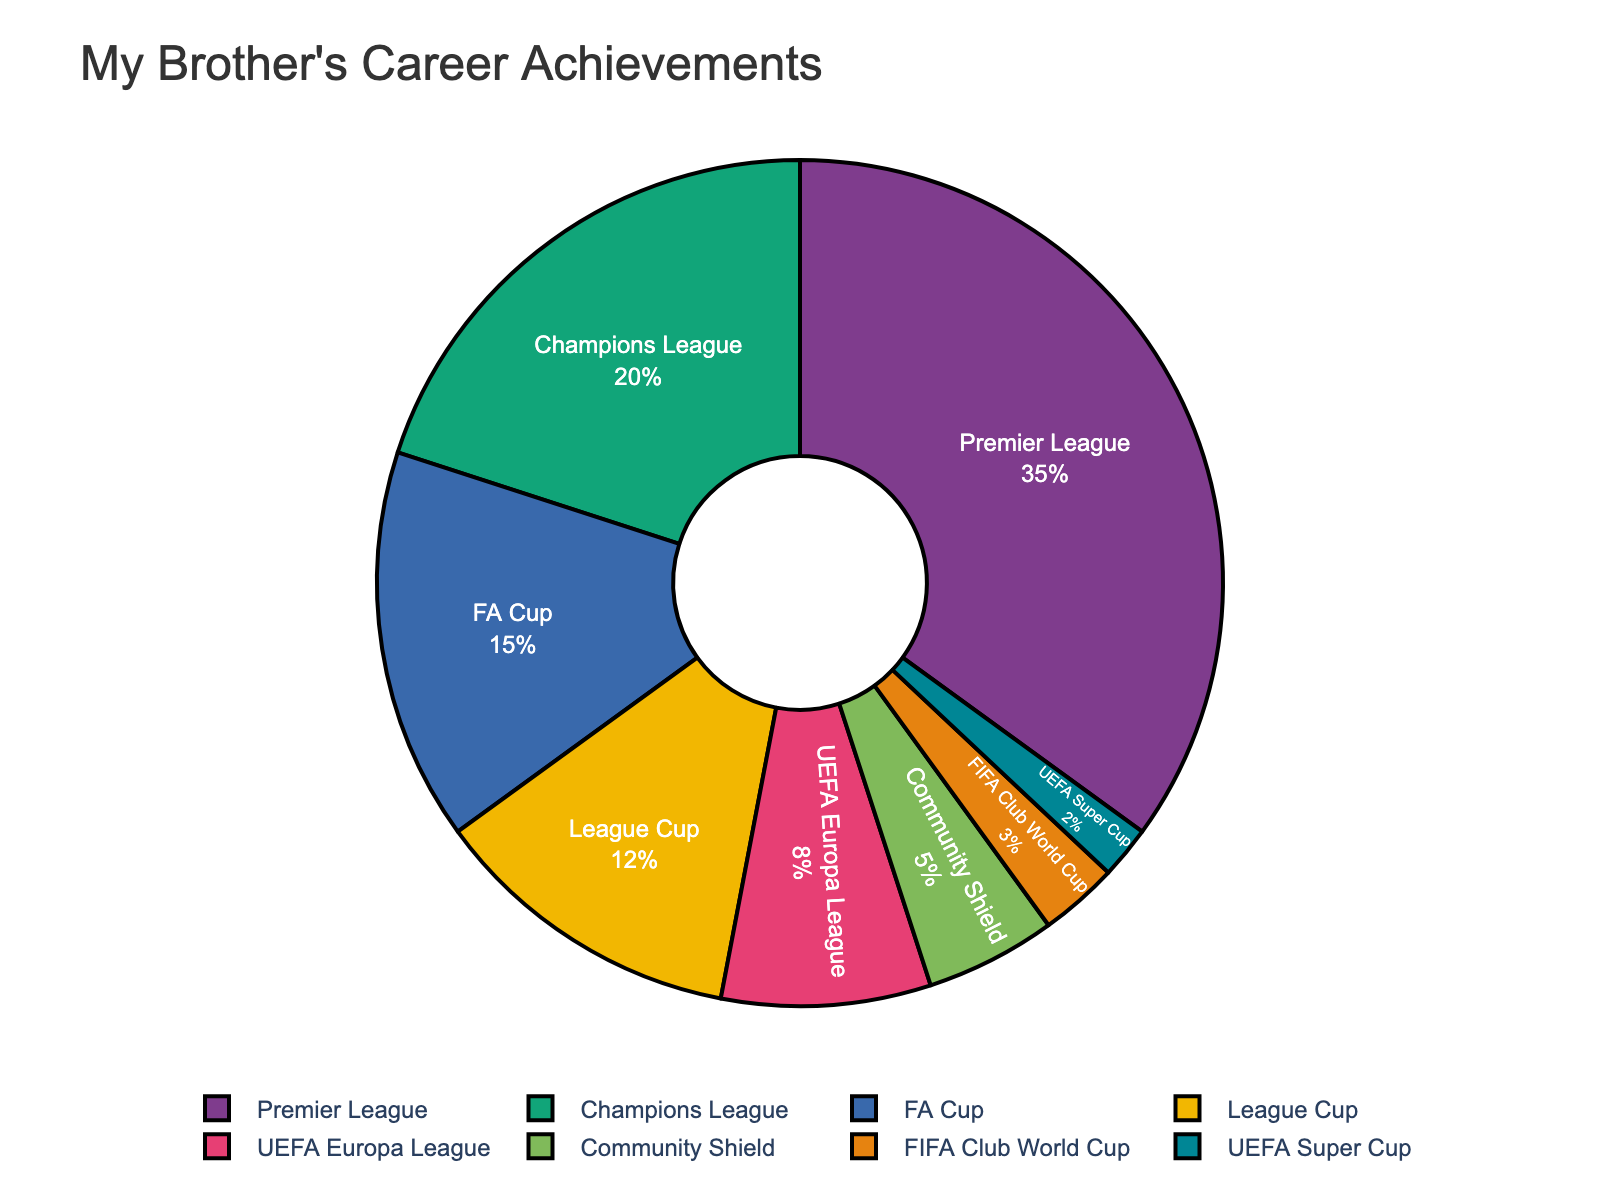Which tournament/league occupies the largest percentage of my brother's career achievements? The Premier League is shown as the largest section of the pie chart, occupying 35% of the total.
Answer: Premier League What is the combined percentage of career achievements in UEFA tournaments (Champions League, UEFA Europa League, UEFA Super Cup)? Sum the percentages of the Champions League (20%), UEFA Europa League (8%), and UEFA Super Cup (2%). 20% + 8% + 2% = 30%
Answer: 30% How does the percentage of FA Cup achievements compare to the League Cup achievements? The pie chart shows that the FA Cup accounts for 15% and the League Cup for 12% of the career achievements. 15% is greater than 12%.
Answer: FA Cup is greater Which tournament or league has the smallest percentage breakdown in my brother's career achievements? The smallest section of the pie chart is the UEFA Super Cup, with 2%.
Answer: UEFA Super Cup What is the difference in percentage between the Community Shield and FIFA Club World Cup achievements? Subtract the percentage for FIFA Club World Cup (3%) from the percentage for Community Shield (5%). 5% - 3% = 2%
Answer: 2% Are there more career achievements in the Champions League or in all domestic cups combined (FA Cup, League Cup, Community Shield)? Calculate the combined total for domestic cups: FA Cup (15%) + League Cup (12%) + Community Shield (5%) = 32%. Compare this with the Champions League (20%). 32% is greater than 20%.
Answer: Domestic cups are greater What percentage of career achievements are attributed to non-European tournaments and leagues (FIFA Club World Cup)? The only non-European tournament mentioned in the data is the FIFA Club World Cup, which accounts for 3%.
Answer: 3% If the percentages for Premier League and the Champions League achievements are combined, what proportion of my brother's career achievements do they represent? Sum the percentages for the Premier League (35%) and Champions League (20%). 35% + 20% = 55%
Answer: 55% What is the average percentage of career achievements for the FA Cup, League Cup, and UEFA Europa League? Sum the percentages of FA Cup (15%), League Cup (12%), and UEFA Europa League (8%) and then divide by the number of leagues (3). (15% + 12% + 8%) / 3 = 35% / 3 = 11.67%
Answer: 11.67% Which tournament/league accounts for twice as much or more of the career achievements compared to the UEFA Europa League? The UEFA Europa League accounts for 8%. The Premier League (35%), Champions League (20%), and FA Cup (15%) are all equal to or more than twice 8%.
Answer: Premier League, Champions League, FA Cup 